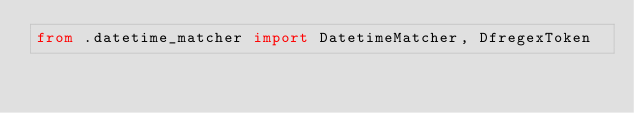<code> <loc_0><loc_0><loc_500><loc_500><_Python_>from .datetime_matcher import DatetimeMatcher, DfregexToken</code> 